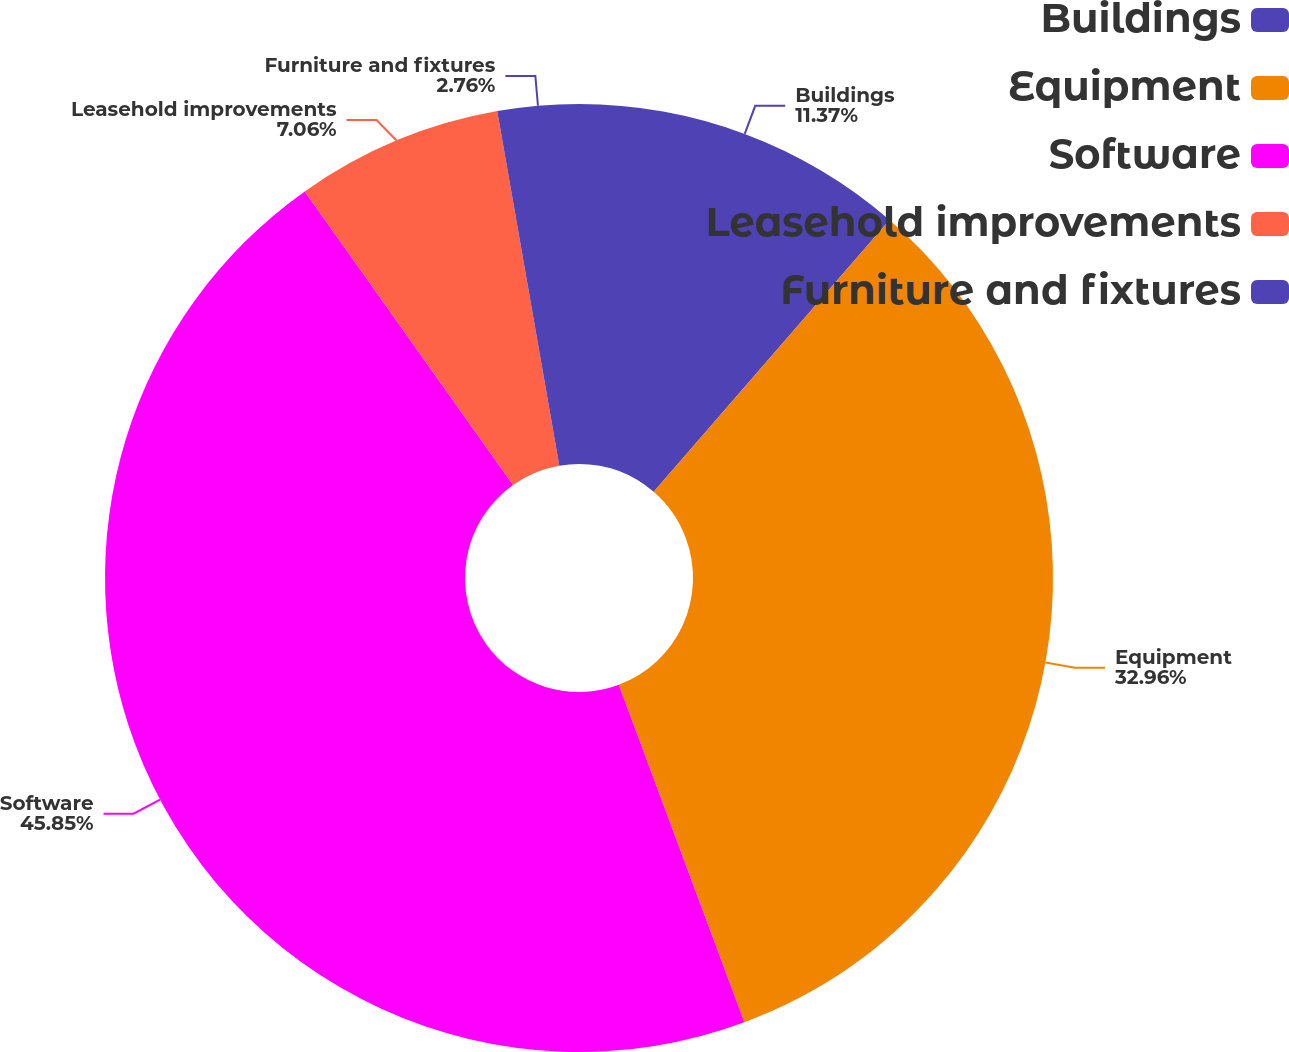Convert chart to OTSL. <chart><loc_0><loc_0><loc_500><loc_500><pie_chart><fcel>Buildings<fcel>Equipment<fcel>Software<fcel>Leasehold improvements<fcel>Furniture and fixtures<nl><fcel>11.37%<fcel>32.96%<fcel>45.85%<fcel>7.06%<fcel>2.76%<nl></chart> 